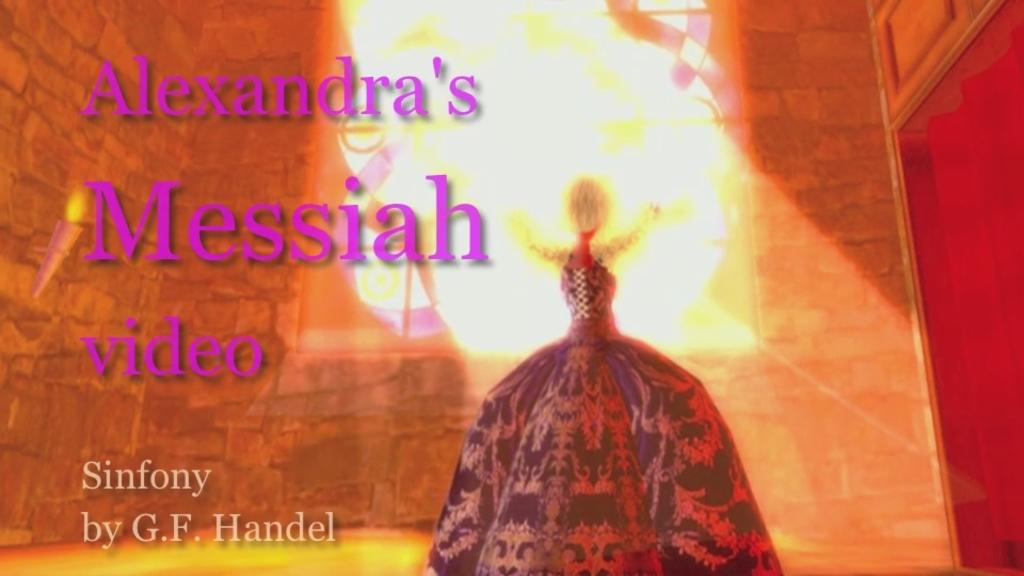<image>
Render a clear and concise summary of the photo. Poster showing a woman and the name Alexandra on the top. 